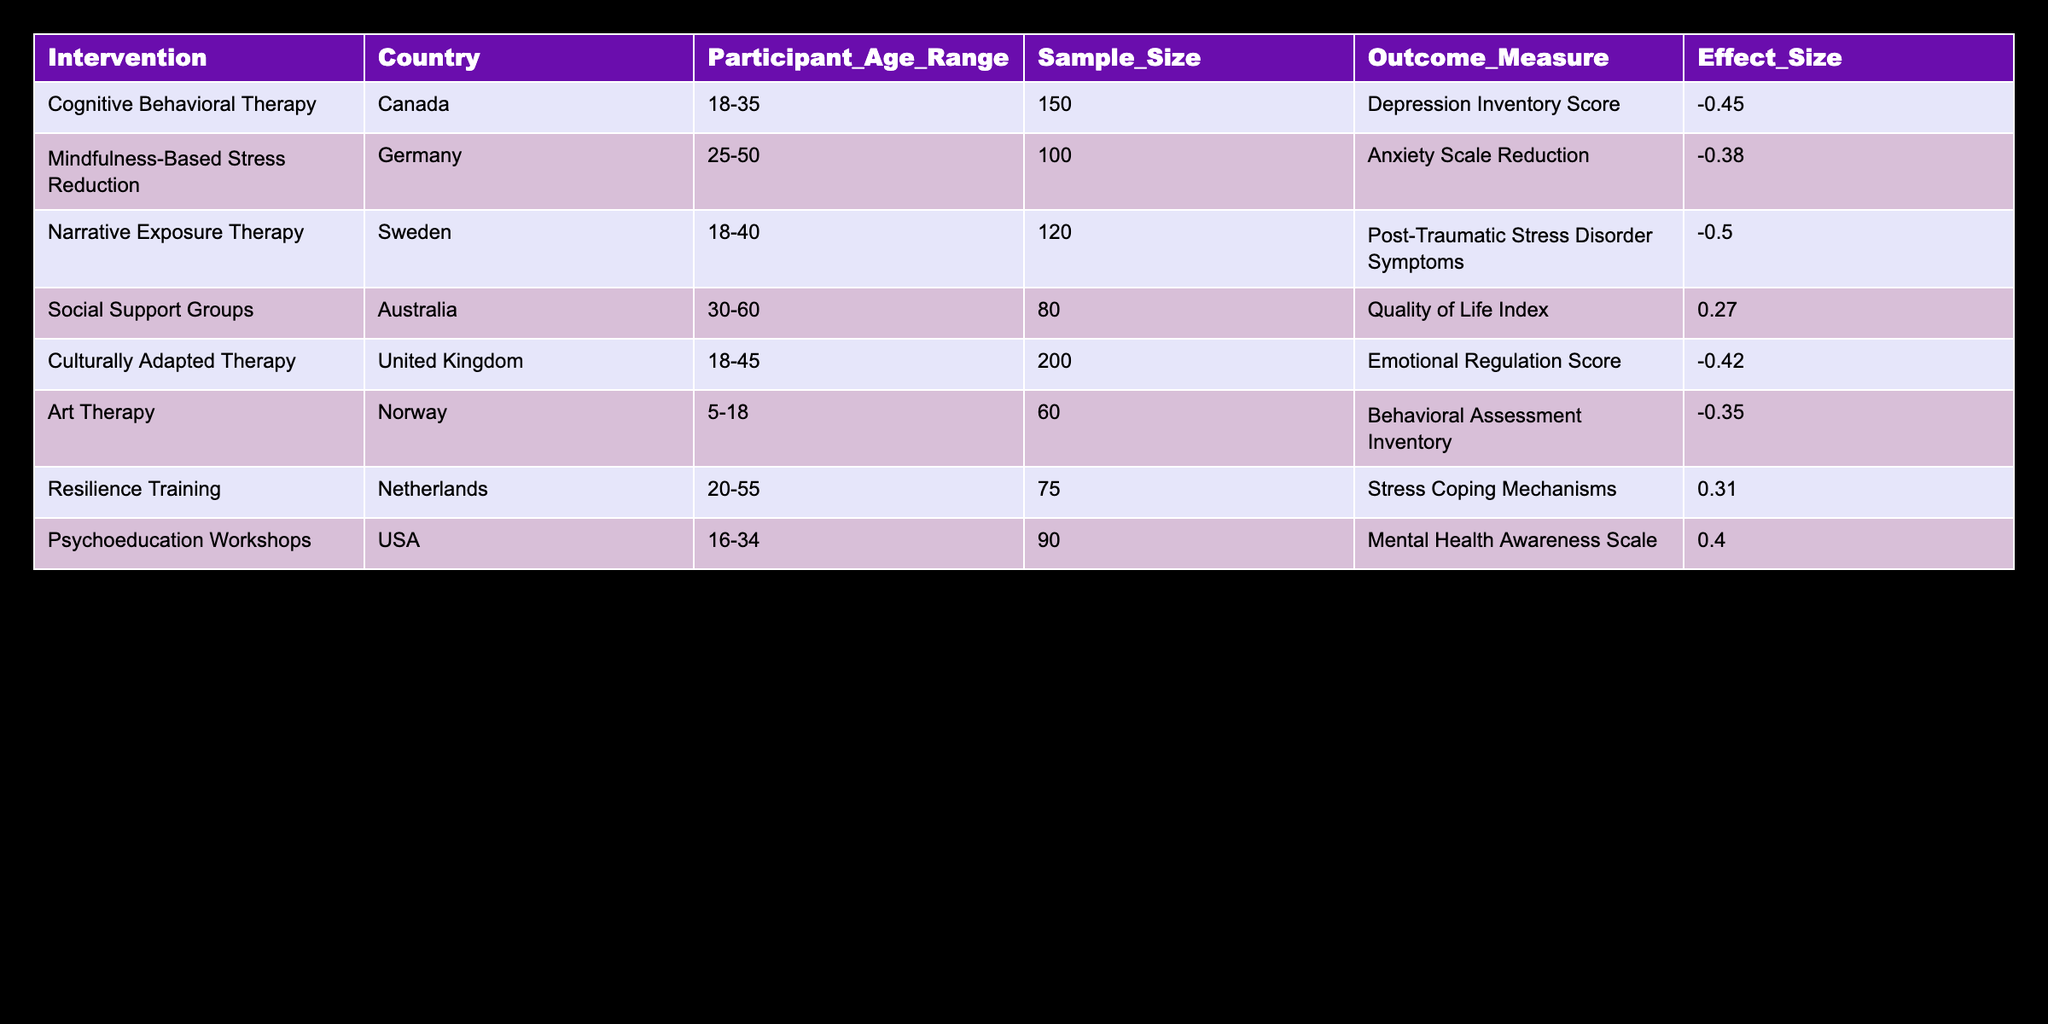What is the highest effect size reported in the table? The highest effect size in the table can be found by inspecting the values in the "Effect Size" column. The highest value is -0.50, associated with Narrative Exposure Therapy in Sweden.
Answer: -0.50 Which intervention had the largest sample size? In the "Sample Size" column, we identify the largest number. The largest sample size is 200, corresponding to Culturally Adapted Therapy in the United Kingdom.
Answer: 200 Are there any interventions that reported a positive effect size? We check the "Effect Size" column for positive values. The interventions with positive effect sizes are Social Support Groups, Resilience Training, and Psychoeducation Workshops (0.27, 0.31, 0.40 respectively). Therefore, there are interventions with positive effect sizes.
Answer: Yes What is the average effect size of all interventions listed? To determine the average effect size, we sum all the effect sizes: (-0.45) + (-0.38) + (-0.50) + 0.27 + (-0.42) + (-0.35) + 0.31 + 0.40 = -0.12. We then divide by the number of interventions (8): -0.12 / 8 = -0.015. The average effect size is approximately -0.015.
Answer: -0.015 Is there an intervention targeting participants under 18 years of age? We review the "Participant Age Range" column for any entry less than 18 years. The table shows that Art Therapy in Norway targets participants aged 5-18, confirming that there is indeed an intervention for this age group.
Answer: Yes Which country reported the intervention with the lowest effect size? We need to find the lowest effect size from the "Effect Size" column. The lowest value is -0.50, associated with Narrative Exposure Therapy in Sweden. Thus, Sweden reported the intervention with the lowest effect size.
Answer: Sweden How many interventions were conducted in English-speaking countries? We identify the interventions conducted in English-speaking countries from the "Country" column: Canada, United Kingdom, and USA. This gives a total of three interventions conducted in English-speaking countries.
Answer: 3 What is the difference in effect size between Mindfulness-Based Stress Reduction and Culturally Adapted Therapy? We look at the effect sizes for both interventions. Mindfulness-Based Stress Reduction has an effect size of -0.38, and Culturally Adapted Therapy has an effect size of -0.42. To find the difference, we subtract: -0.38 - (-0.42) = 0.04, indicating that Mindfulness-Based Stress Reduction has a higher effect size by 0.04.
Answer: 0.04 